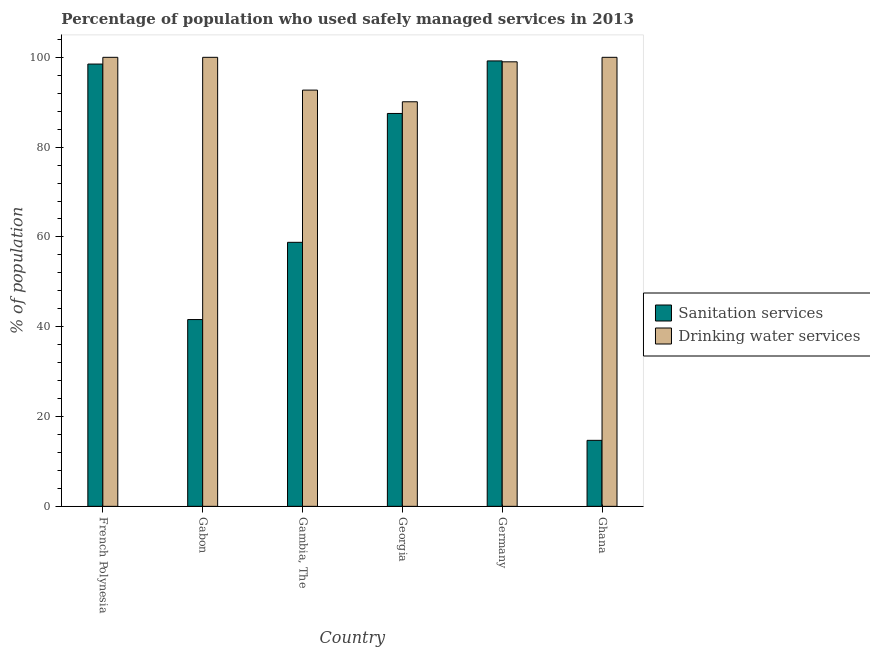Are the number of bars per tick equal to the number of legend labels?
Your response must be concise. Yes. How many bars are there on the 1st tick from the left?
Keep it short and to the point. 2. What is the label of the 4th group of bars from the left?
Give a very brief answer. Georgia. In how many cases, is the number of bars for a given country not equal to the number of legend labels?
Your answer should be very brief. 0. What is the percentage of population who used drinking water services in Germany?
Your answer should be very brief. 99. Across all countries, what is the maximum percentage of population who used sanitation services?
Your answer should be very brief. 99.2. Across all countries, what is the minimum percentage of population who used drinking water services?
Give a very brief answer. 90.1. In which country was the percentage of population who used sanitation services maximum?
Ensure brevity in your answer.  Germany. In which country was the percentage of population who used sanitation services minimum?
Your response must be concise. Ghana. What is the total percentage of population who used sanitation services in the graph?
Provide a succinct answer. 400.3. What is the difference between the percentage of population who used drinking water services in Georgia and that in Ghana?
Make the answer very short. -9.9. What is the difference between the percentage of population who used drinking water services in Ghana and the percentage of population who used sanitation services in Germany?
Provide a succinct answer. 0.8. What is the average percentage of population who used sanitation services per country?
Make the answer very short. 66.72. What is the difference between the percentage of population who used sanitation services and percentage of population who used drinking water services in Gambia, The?
Make the answer very short. -33.9. In how many countries, is the percentage of population who used sanitation services greater than 48 %?
Keep it short and to the point. 4. What is the ratio of the percentage of population who used drinking water services in Gabon to that in Ghana?
Make the answer very short. 1. Is the percentage of population who used drinking water services in French Polynesia less than that in Gabon?
Provide a short and direct response. No. What is the difference between the highest and the second highest percentage of population who used drinking water services?
Ensure brevity in your answer.  0. What is the difference between the highest and the lowest percentage of population who used drinking water services?
Provide a succinct answer. 9.9. In how many countries, is the percentage of population who used drinking water services greater than the average percentage of population who used drinking water services taken over all countries?
Your answer should be compact. 4. Is the sum of the percentage of population who used drinking water services in Georgia and Ghana greater than the maximum percentage of population who used sanitation services across all countries?
Keep it short and to the point. Yes. What does the 2nd bar from the left in Gabon represents?
Your answer should be very brief. Drinking water services. What does the 1st bar from the right in Georgia represents?
Ensure brevity in your answer.  Drinking water services. Are all the bars in the graph horizontal?
Your answer should be very brief. No. What is the difference between two consecutive major ticks on the Y-axis?
Give a very brief answer. 20. Are the values on the major ticks of Y-axis written in scientific E-notation?
Offer a very short reply. No. What is the title of the graph?
Ensure brevity in your answer.  Percentage of population who used safely managed services in 2013. Does "Girls" appear as one of the legend labels in the graph?
Make the answer very short. No. What is the label or title of the Y-axis?
Ensure brevity in your answer.  % of population. What is the % of population of Sanitation services in French Polynesia?
Keep it short and to the point. 98.5. What is the % of population in Sanitation services in Gabon?
Provide a short and direct response. 41.6. What is the % of population of Drinking water services in Gabon?
Your answer should be compact. 100. What is the % of population in Sanitation services in Gambia, The?
Make the answer very short. 58.8. What is the % of population in Drinking water services in Gambia, The?
Make the answer very short. 92.7. What is the % of population in Sanitation services in Georgia?
Keep it short and to the point. 87.5. What is the % of population of Drinking water services in Georgia?
Keep it short and to the point. 90.1. What is the % of population of Sanitation services in Germany?
Make the answer very short. 99.2. What is the % of population of Drinking water services in Ghana?
Make the answer very short. 100. Across all countries, what is the maximum % of population of Sanitation services?
Your answer should be compact. 99.2. Across all countries, what is the minimum % of population of Sanitation services?
Ensure brevity in your answer.  14.7. Across all countries, what is the minimum % of population in Drinking water services?
Ensure brevity in your answer.  90.1. What is the total % of population of Sanitation services in the graph?
Your answer should be very brief. 400.3. What is the total % of population of Drinking water services in the graph?
Your answer should be very brief. 581.8. What is the difference between the % of population of Sanitation services in French Polynesia and that in Gabon?
Your answer should be very brief. 56.9. What is the difference between the % of population of Sanitation services in French Polynesia and that in Gambia, The?
Your response must be concise. 39.7. What is the difference between the % of population of Drinking water services in French Polynesia and that in Georgia?
Your response must be concise. 9.9. What is the difference between the % of population of Sanitation services in French Polynesia and that in Germany?
Keep it short and to the point. -0.7. What is the difference between the % of population in Drinking water services in French Polynesia and that in Germany?
Ensure brevity in your answer.  1. What is the difference between the % of population in Sanitation services in French Polynesia and that in Ghana?
Provide a succinct answer. 83.8. What is the difference between the % of population of Sanitation services in Gabon and that in Gambia, The?
Your answer should be compact. -17.2. What is the difference between the % of population in Drinking water services in Gabon and that in Gambia, The?
Keep it short and to the point. 7.3. What is the difference between the % of population in Sanitation services in Gabon and that in Georgia?
Provide a succinct answer. -45.9. What is the difference between the % of population in Sanitation services in Gabon and that in Germany?
Offer a terse response. -57.6. What is the difference between the % of population of Drinking water services in Gabon and that in Germany?
Give a very brief answer. 1. What is the difference between the % of population in Sanitation services in Gabon and that in Ghana?
Offer a very short reply. 26.9. What is the difference between the % of population of Drinking water services in Gabon and that in Ghana?
Provide a succinct answer. 0. What is the difference between the % of population of Sanitation services in Gambia, The and that in Georgia?
Offer a terse response. -28.7. What is the difference between the % of population in Sanitation services in Gambia, The and that in Germany?
Provide a succinct answer. -40.4. What is the difference between the % of population in Drinking water services in Gambia, The and that in Germany?
Offer a terse response. -6.3. What is the difference between the % of population of Sanitation services in Gambia, The and that in Ghana?
Provide a succinct answer. 44.1. What is the difference between the % of population in Drinking water services in Gambia, The and that in Ghana?
Make the answer very short. -7.3. What is the difference between the % of population in Sanitation services in Georgia and that in Germany?
Give a very brief answer. -11.7. What is the difference between the % of population of Sanitation services in Georgia and that in Ghana?
Make the answer very short. 72.8. What is the difference between the % of population in Sanitation services in Germany and that in Ghana?
Offer a terse response. 84.5. What is the difference between the % of population in Drinking water services in Germany and that in Ghana?
Offer a very short reply. -1. What is the difference between the % of population in Sanitation services in French Polynesia and the % of population in Drinking water services in Gabon?
Give a very brief answer. -1.5. What is the difference between the % of population in Sanitation services in French Polynesia and the % of population in Drinking water services in Gambia, The?
Keep it short and to the point. 5.8. What is the difference between the % of population in Sanitation services in French Polynesia and the % of population in Drinking water services in Georgia?
Provide a succinct answer. 8.4. What is the difference between the % of population in Sanitation services in French Polynesia and the % of population in Drinking water services in Germany?
Your answer should be very brief. -0.5. What is the difference between the % of population in Sanitation services in French Polynesia and the % of population in Drinking water services in Ghana?
Offer a very short reply. -1.5. What is the difference between the % of population in Sanitation services in Gabon and the % of population in Drinking water services in Gambia, The?
Give a very brief answer. -51.1. What is the difference between the % of population of Sanitation services in Gabon and the % of population of Drinking water services in Georgia?
Your answer should be compact. -48.5. What is the difference between the % of population in Sanitation services in Gabon and the % of population in Drinking water services in Germany?
Provide a short and direct response. -57.4. What is the difference between the % of population in Sanitation services in Gabon and the % of population in Drinking water services in Ghana?
Your answer should be compact. -58.4. What is the difference between the % of population of Sanitation services in Gambia, The and the % of population of Drinking water services in Georgia?
Offer a terse response. -31.3. What is the difference between the % of population in Sanitation services in Gambia, The and the % of population in Drinking water services in Germany?
Offer a very short reply. -40.2. What is the difference between the % of population in Sanitation services in Gambia, The and the % of population in Drinking water services in Ghana?
Provide a succinct answer. -41.2. What is the difference between the % of population in Sanitation services in Georgia and the % of population in Drinking water services in Germany?
Your answer should be compact. -11.5. What is the difference between the % of population in Sanitation services in Germany and the % of population in Drinking water services in Ghana?
Make the answer very short. -0.8. What is the average % of population in Sanitation services per country?
Provide a succinct answer. 66.72. What is the average % of population of Drinking water services per country?
Make the answer very short. 96.97. What is the difference between the % of population in Sanitation services and % of population in Drinking water services in French Polynesia?
Your answer should be compact. -1.5. What is the difference between the % of population in Sanitation services and % of population in Drinking water services in Gabon?
Give a very brief answer. -58.4. What is the difference between the % of population in Sanitation services and % of population in Drinking water services in Gambia, The?
Ensure brevity in your answer.  -33.9. What is the difference between the % of population in Sanitation services and % of population in Drinking water services in Ghana?
Give a very brief answer. -85.3. What is the ratio of the % of population of Sanitation services in French Polynesia to that in Gabon?
Ensure brevity in your answer.  2.37. What is the ratio of the % of population in Drinking water services in French Polynesia to that in Gabon?
Provide a succinct answer. 1. What is the ratio of the % of population in Sanitation services in French Polynesia to that in Gambia, The?
Provide a succinct answer. 1.68. What is the ratio of the % of population of Drinking water services in French Polynesia to that in Gambia, The?
Your answer should be very brief. 1.08. What is the ratio of the % of population of Sanitation services in French Polynesia to that in Georgia?
Make the answer very short. 1.13. What is the ratio of the % of population of Drinking water services in French Polynesia to that in Georgia?
Give a very brief answer. 1.11. What is the ratio of the % of population in Sanitation services in French Polynesia to that in Ghana?
Make the answer very short. 6.7. What is the ratio of the % of population of Drinking water services in French Polynesia to that in Ghana?
Your answer should be very brief. 1. What is the ratio of the % of population of Sanitation services in Gabon to that in Gambia, The?
Provide a short and direct response. 0.71. What is the ratio of the % of population in Drinking water services in Gabon to that in Gambia, The?
Provide a short and direct response. 1.08. What is the ratio of the % of population of Sanitation services in Gabon to that in Georgia?
Give a very brief answer. 0.48. What is the ratio of the % of population of Drinking water services in Gabon to that in Georgia?
Make the answer very short. 1.11. What is the ratio of the % of population of Sanitation services in Gabon to that in Germany?
Provide a succinct answer. 0.42. What is the ratio of the % of population in Sanitation services in Gabon to that in Ghana?
Offer a terse response. 2.83. What is the ratio of the % of population of Drinking water services in Gabon to that in Ghana?
Keep it short and to the point. 1. What is the ratio of the % of population in Sanitation services in Gambia, The to that in Georgia?
Offer a very short reply. 0.67. What is the ratio of the % of population of Drinking water services in Gambia, The to that in Georgia?
Ensure brevity in your answer.  1.03. What is the ratio of the % of population of Sanitation services in Gambia, The to that in Germany?
Your answer should be compact. 0.59. What is the ratio of the % of population in Drinking water services in Gambia, The to that in Germany?
Keep it short and to the point. 0.94. What is the ratio of the % of population in Drinking water services in Gambia, The to that in Ghana?
Offer a terse response. 0.93. What is the ratio of the % of population in Sanitation services in Georgia to that in Germany?
Your answer should be very brief. 0.88. What is the ratio of the % of population of Drinking water services in Georgia to that in Germany?
Offer a terse response. 0.91. What is the ratio of the % of population in Sanitation services in Georgia to that in Ghana?
Ensure brevity in your answer.  5.95. What is the ratio of the % of population in Drinking water services in Georgia to that in Ghana?
Your response must be concise. 0.9. What is the ratio of the % of population of Sanitation services in Germany to that in Ghana?
Offer a terse response. 6.75. What is the difference between the highest and the lowest % of population in Sanitation services?
Offer a very short reply. 84.5. What is the difference between the highest and the lowest % of population in Drinking water services?
Your response must be concise. 9.9. 